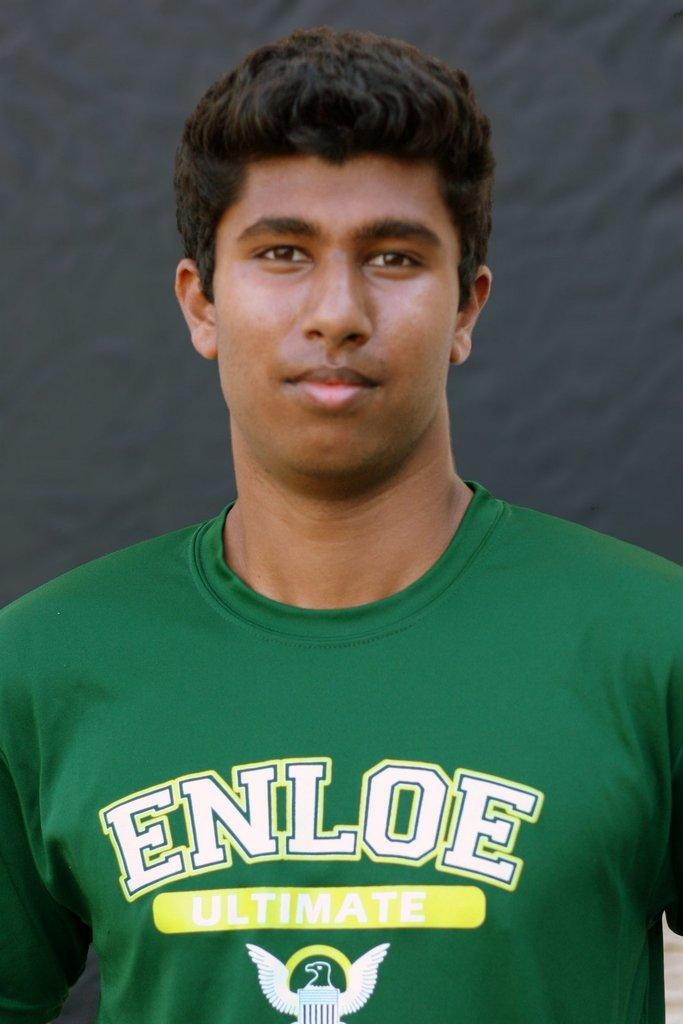<image>
Give a short and clear explanation of the subsequent image. a portrait of a man in an Enloe Ultimate shirt 